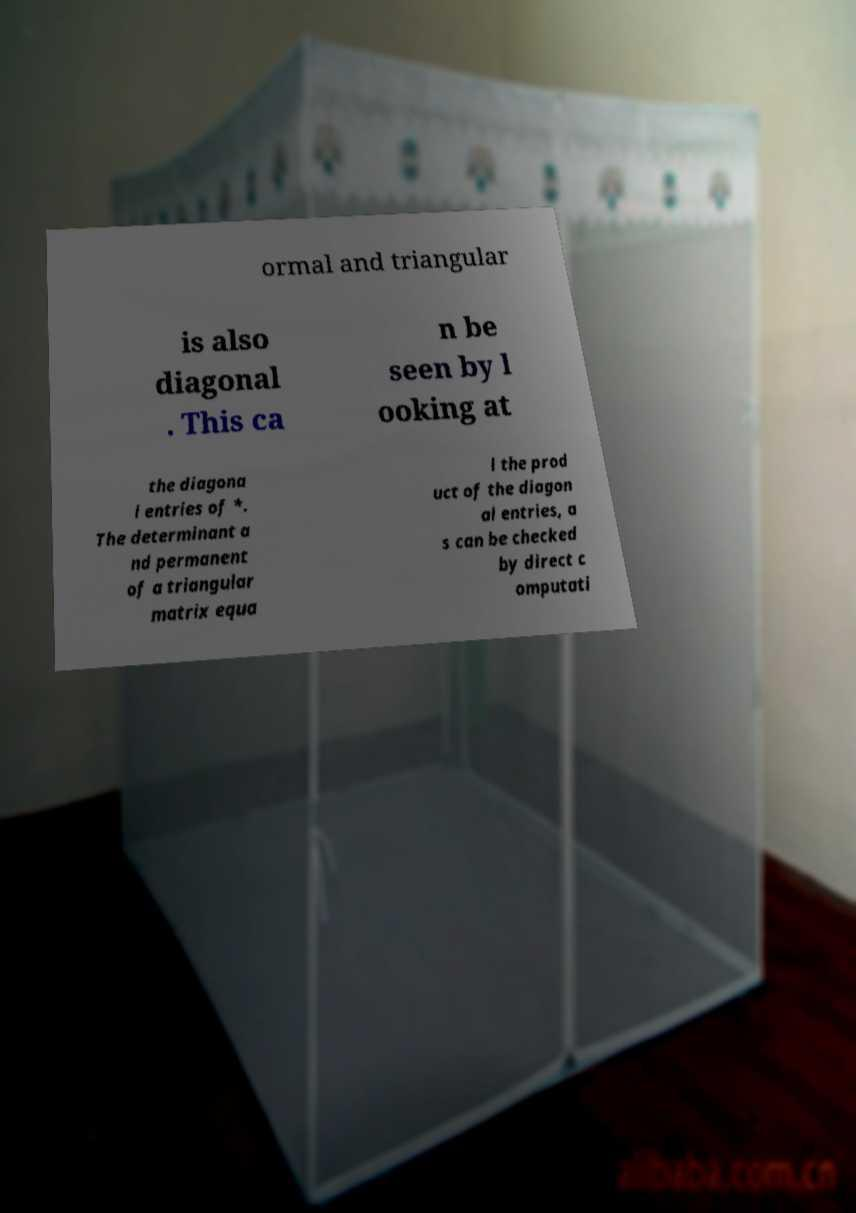Please read and relay the text visible in this image. What does it say? ormal and triangular is also diagonal . This ca n be seen by l ooking at the diagona l entries of *. The determinant a nd permanent of a triangular matrix equa l the prod uct of the diagon al entries, a s can be checked by direct c omputati 